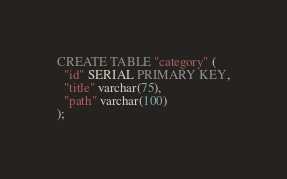<code> <loc_0><loc_0><loc_500><loc_500><_SQL_>CREATE TABLE "category" (
  "id" SERIAL PRIMARY KEY,
  "title" varchar(75),
  "path" varchar(100)
);</code> 